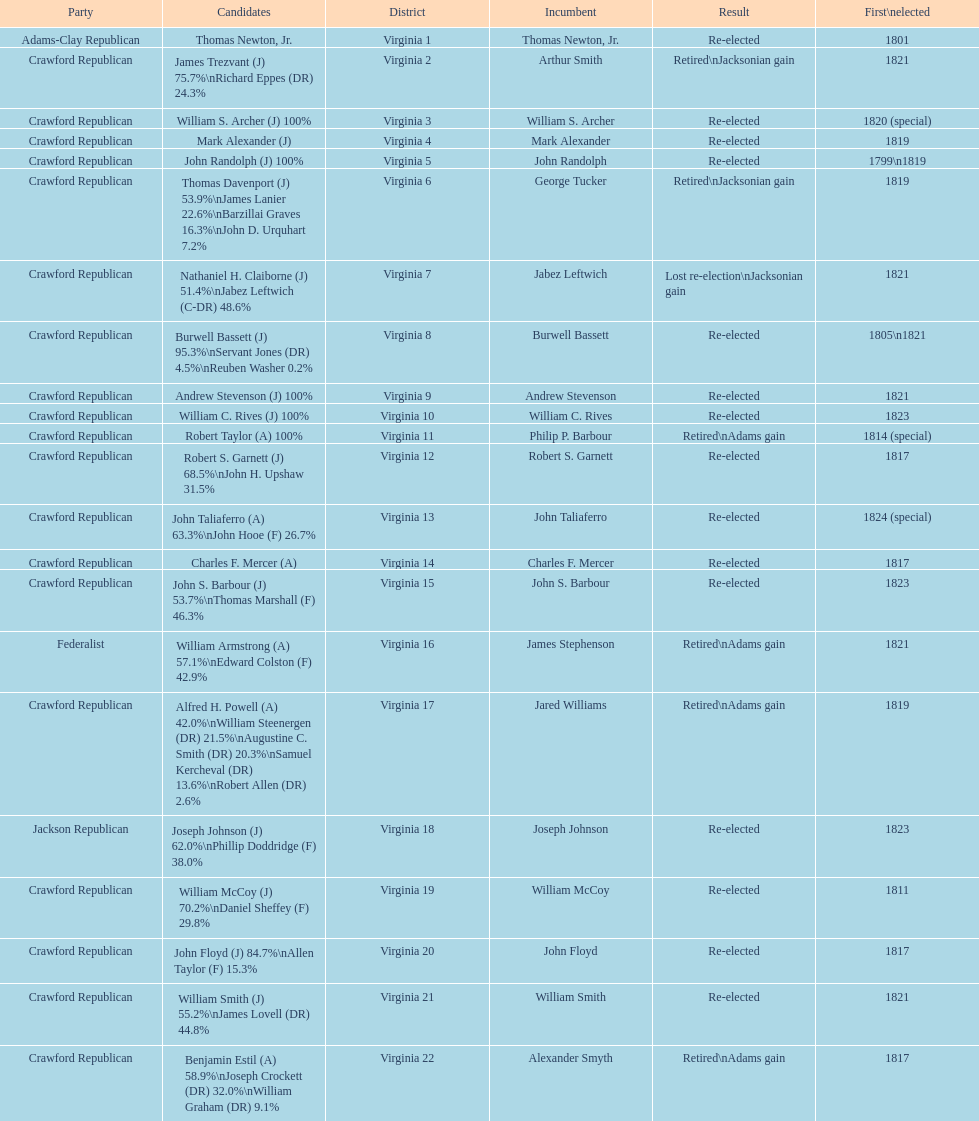How many districts are there in virginia? 22. 